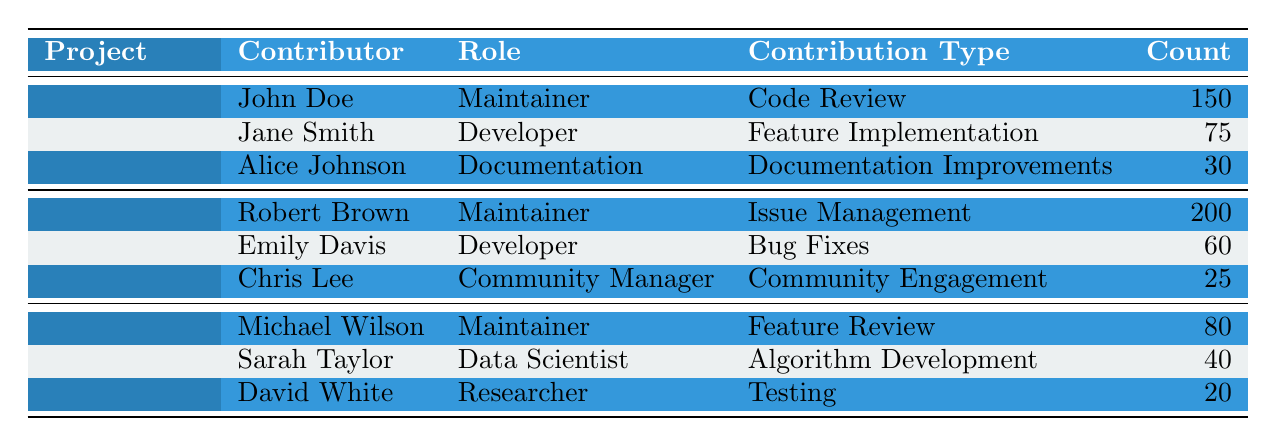What is the contribution count for John Doe in TensorFlow? From the table, John Doe is listed as a contributor for the TensorFlow project with a contribution count of 150.
Answer: 150 How many contributors are listed for the PyTorch project? The table shows three contributors for the PyTorch project: Robert Brown, Emily Davis, and Chris Lee.
Answer: 3 Which project has the highest contribution count in a single contribution type? By examining the contribution counts, Robert Brown in the PyTorch project has the highest contribution count of 200 in issue management.
Answer: PyTorch What is the total contribution count for all contributors in TensorFlow? To find this, we sum John Doe's contributions (150), Jane Smith's contributions (75), and Alice Johnson's contributions (30). The total is 150 + 75 + 30 = 255.
Answer: 255 Is Chris Lee a maintainer for PyTorch? The table specifies that Chris Lee's role is a community manager, not a maintainer.
Answer: No Which project has the lowest total contribution count from its contributors? For Scikit-learn, the contributions are 80, 40, and 20, which total 140, the lowest compared to TensorFlow (255) and PyTorch (285).
Answer: Scikit-learn Who contributed the least in the TensorFlow project, and what was their contribution count? Among the contributors listed for TensorFlow, Alice Johnson has the least contribution count at 30 for documentation improvements.
Answer: Alice Johnson, 30 What is the average contribution count of the contributors in Scikit-learn? We first sum the contribution counts (80 + 40 + 20 = 140), then divide by the number of contributors (3), which gives us an average of 140/3 ≈ 46.67.
Answer: 46.67 Which contributor has the most diverse contribution type in TensorFlow? The table does not directly provide diversity metrics, but analyzing the types of contributions, John Doe is a maintainer focused on code review, while other contributors focus on specific feature implementations or documentation improvements. This indicates John Doe's role is relatively broader.
Answer: John Doe 